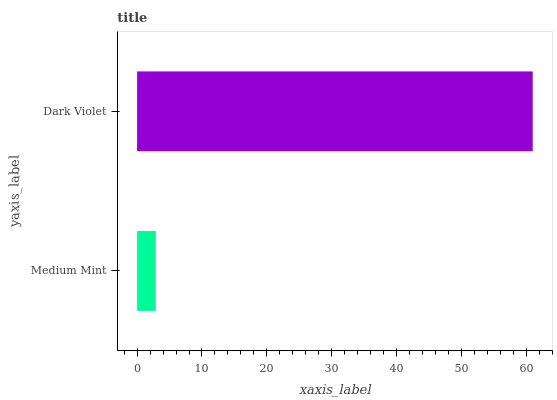Is Medium Mint the minimum?
Answer yes or no. Yes. Is Dark Violet the maximum?
Answer yes or no. Yes. Is Dark Violet the minimum?
Answer yes or no. No. Is Dark Violet greater than Medium Mint?
Answer yes or no. Yes. Is Medium Mint less than Dark Violet?
Answer yes or no. Yes. Is Medium Mint greater than Dark Violet?
Answer yes or no. No. Is Dark Violet less than Medium Mint?
Answer yes or no. No. Is Dark Violet the high median?
Answer yes or no. Yes. Is Medium Mint the low median?
Answer yes or no. Yes. Is Medium Mint the high median?
Answer yes or no. No. Is Dark Violet the low median?
Answer yes or no. No. 